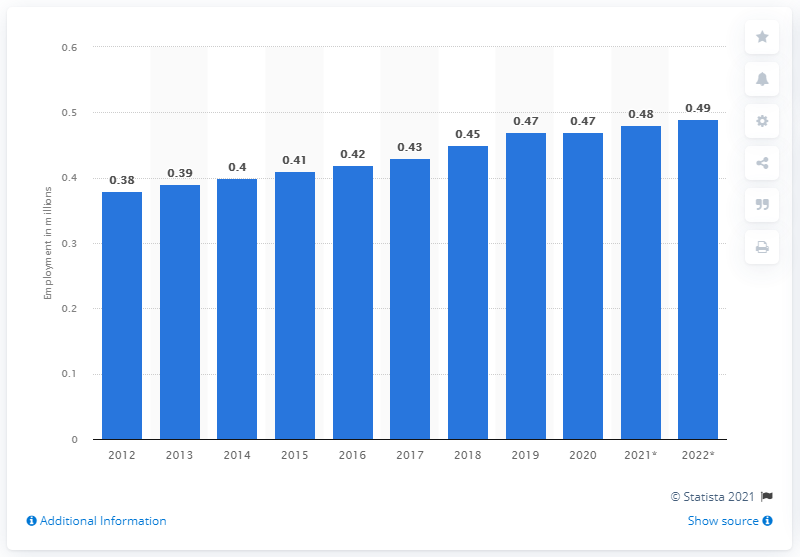Specify some key components in this picture. In 2020, Luxembourg reached its peak in employment. In 2020, Luxembourg achieved its peak in employment. 